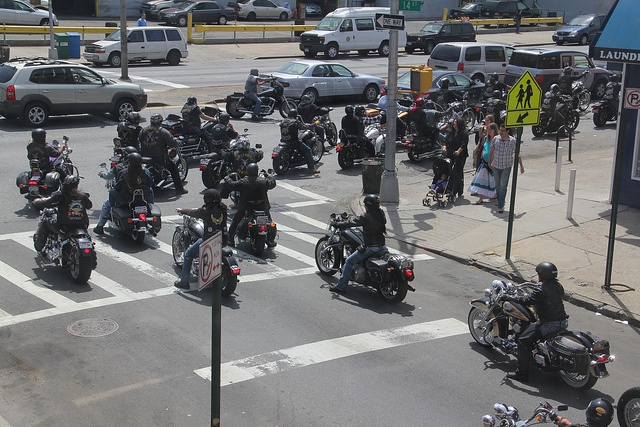Describe the objects in this image and their specific colors. I can see people in darkblue, black, gray, and darkgray tones, motorcycle in darkblue, black, gray, and darkgray tones, car in darkblue, black, gray, darkgray, and lightgray tones, motorcycle in darkblue, black, gray, and darkgray tones, and truck in darkblue, darkgray, black, and gray tones in this image. 